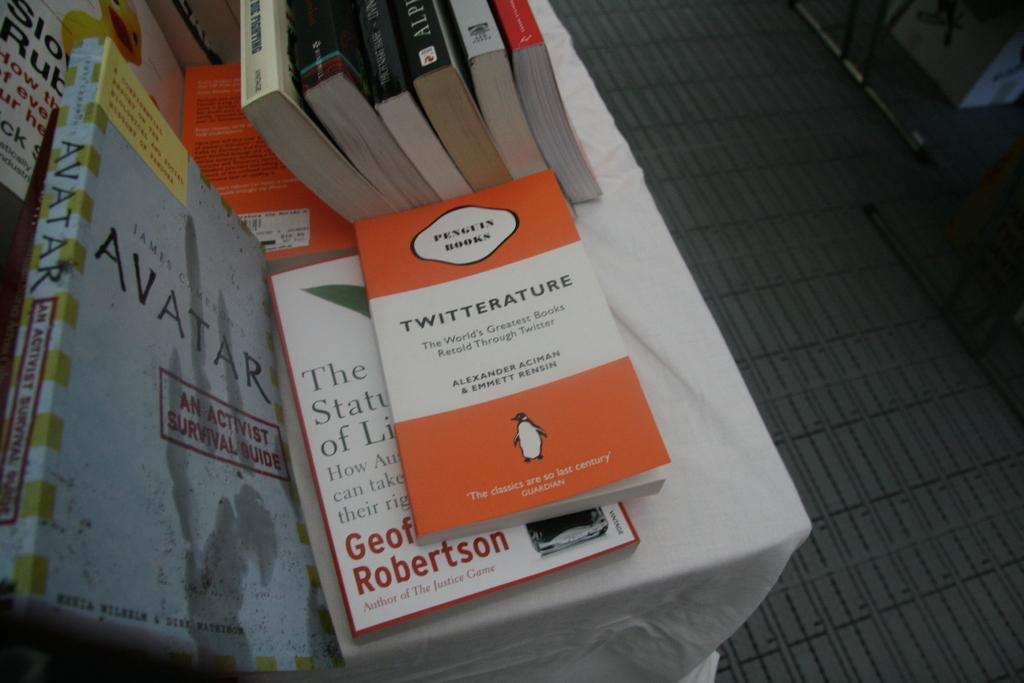<image>
Provide a brief description of the given image. A variety of books are on a table, including Twitterature and Avatar. 